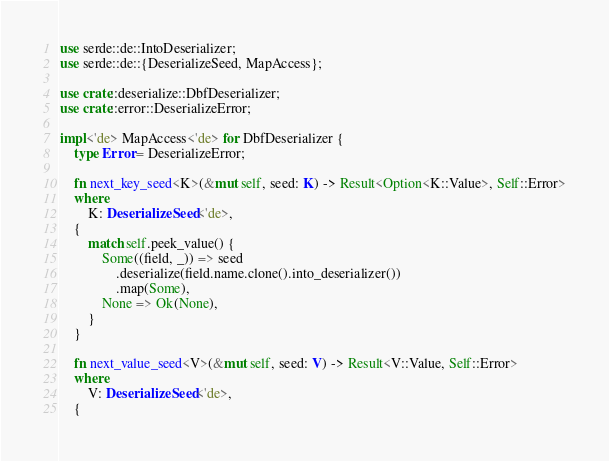Convert code to text. <code><loc_0><loc_0><loc_500><loc_500><_Rust_>use serde::de::IntoDeserializer;
use serde::de::{DeserializeSeed, MapAccess};

use crate::deserialize::DbfDeserializer;
use crate::error::DeserializeError;

impl<'de> MapAccess<'de> for DbfDeserializer {
    type Error = DeserializeError;

    fn next_key_seed<K>(&mut self, seed: K) -> Result<Option<K::Value>, Self::Error>
    where
        K: DeserializeSeed<'de>,
    {
        match self.peek_value() {
            Some((field, _)) => seed
                .deserialize(field.name.clone().into_deserializer())
                .map(Some),
            None => Ok(None),
        }
    }

    fn next_value_seed<V>(&mut self, seed: V) -> Result<V::Value, Self::Error>
    where
        V: DeserializeSeed<'de>,
    {</code> 